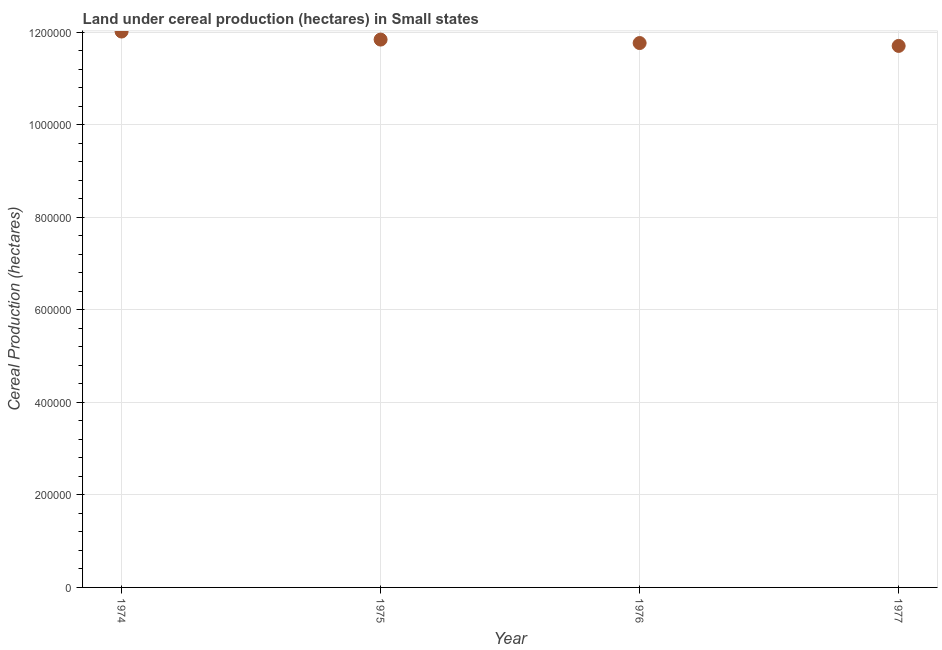What is the land under cereal production in 1977?
Offer a terse response. 1.17e+06. Across all years, what is the maximum land under cereal production?
Make the answer very short. 1.20e+06. Across all years, what is the minimum land under cereal production?
Ensure brevity in your answer.  1.17e+06. In which year was the land under cereal production maximum?
Make the answer very short. 1974. What is the sum of the land under cereal production?
Your response must be concise. 4.73e+06. What is the difference between the land under cereal production in 1974 and 1976?
Your answer should be very brief. 2.49e+04. What is the average land under cereal production per year?
Your answer should be compact. 1.18e+06. What is the median land under cereal production?
Your response must be concise. 1.18e+06. In how many years, is the land under cereal production greater than 720000 hectares?
Your response must be concise. 4. What is the ratio of the land under cereal production in 1974 to that in 1976?
Offer a terse response. 1.02. Is the land under cereal production in 1974 less than that in 1976?
Make the answer very short. No. Is the difference between the land under cereal production in 1976 and 1977 greater than the difference between any two years?
Your answer should be very brief. No. What is the difference between the highest and the second highest land under cereal production?
Your answer should be very brief. 1.74e+04. What is the difference between the highest and the lowest land under cereal production?
Make the answer very short. 3.11e+04. How many years are there in the graph?
Keep it short and to the point. 4. What is the title of the graph?
Provide a short and direct response. Land under cereal production (hectares) in Small states. What is the label or title of the Y-axis?
Give a very brief answer. Cereal Production (hectares). What is the Cereal Production (hectares) in 1974?
Your response must be concise. 1.20e+06. What is the Cereal Production (hectares) in 1975?
Provide a succinct answer. 1.18e+06. What is the Cereal Production (hectares) in 1976?
Offer a very short reply. 1.18e+06. What is the Cereal Production (hectares) in 1977?
Give a very brief answer. 1.17e+06. What is the difference between the Cereal Production (hectares) in 1974 and 1975?
Ensure brevity in your answer.  1.74e+04. What is the difference between the Cereal Production (hectares) in 1974 and 1976?
Offer a terse response. 2.49e+04. What is the difference between the Cereal Production (hectares) in 1974 and 1977?
Your answer should be very brief. 3.11e+04. What is the difference between the Cereal Production (hectares) in 1975 and 1976?
Offer a terse response. 7493. What is the difference between the Cereal Production (hectares) in 1975 and 1977?
Provide a short and direct response. 1.37e+04. What is the difference between the Cereal Production (hectares) in 1976 and 1977?
Provide a succinct answer. 6209. What is the ratio of the Cereal Production (hectares) in 1974 to that in 1975?
Your answer should be compact. 1.01. What is the ratio of the Cereal Production (hectares) in 1974 to that in 1977?
Provide a succinct answer. 1.03. What is the ratio of the Cereal Production (hectares) in 1975 to that in 1976?
Keep it short and to the point. 1.01. What is the ratio of the Cereal Production (hectares) in 1975 to that in 1977?
Give a very brief answer. 1.01. What is the ratio of the Cereal Production (hectares) in 1976 to that in 1977?
Your response must be concise. 1. 